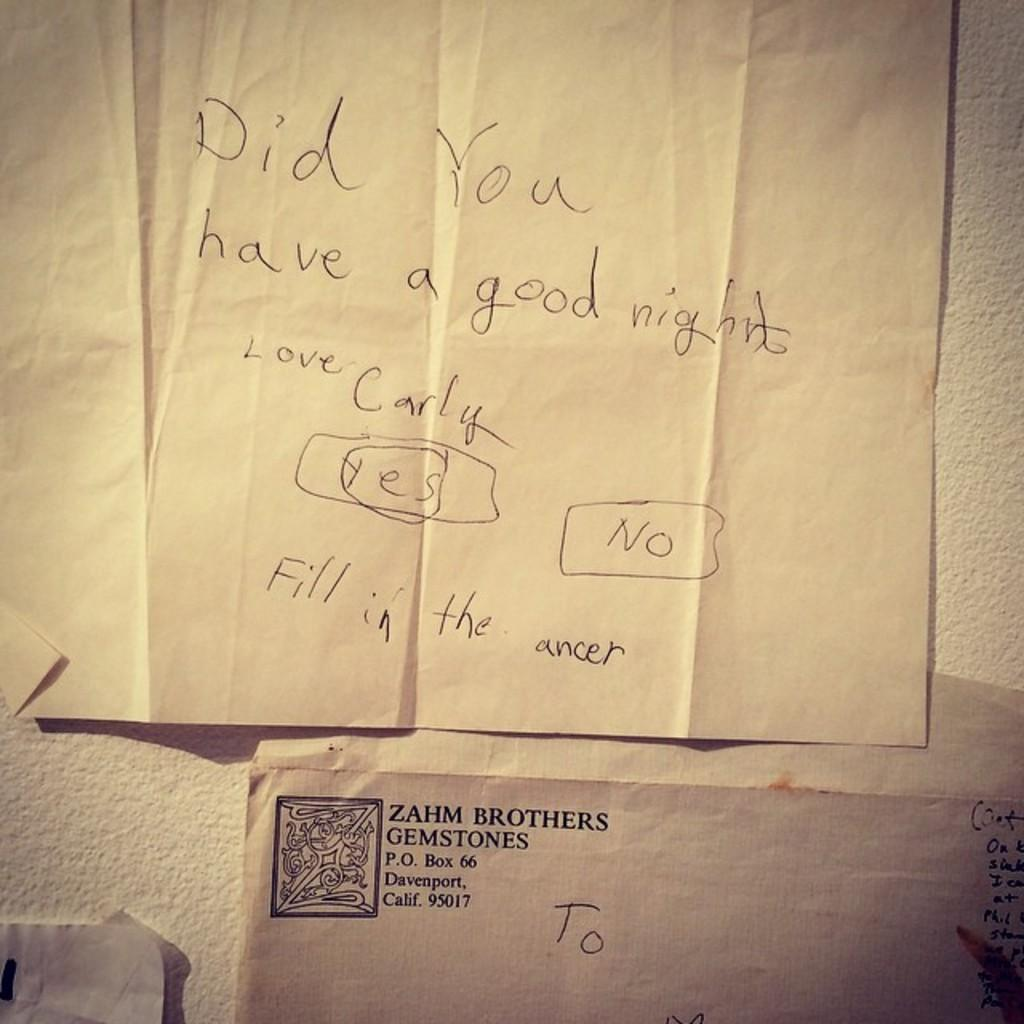<image>
Summarize the visual content of the image. Carly wants to know if some had a good night or not. 